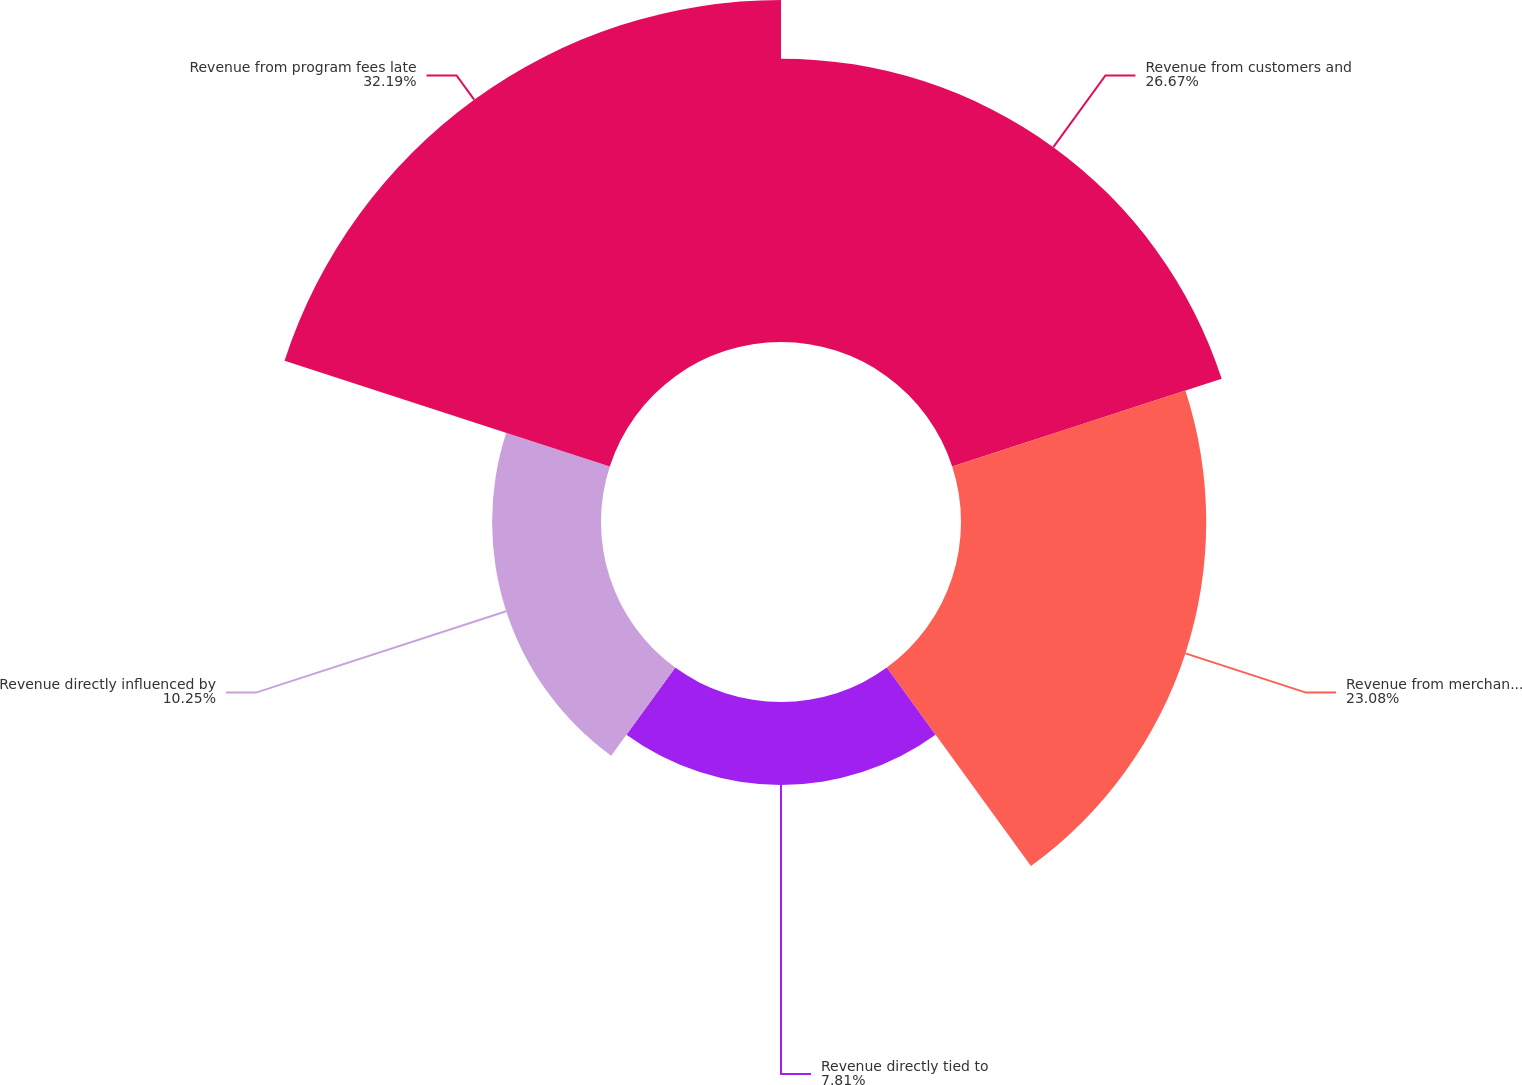<chart> <loc_0><loc_0><loc_500><loc_500><pie_chart><fcel>Revenue from customers and<fcel>Revenue from merchants and<fcel>Revenue directly tied to<fcel>Revenue directly influenced by<fcel>Revenue from program fees late<nl><fcel>26.67%<fcel>23.08%<fcel>7.81%<fcel>10.25%<fcel>32.19%<nl></chart> 